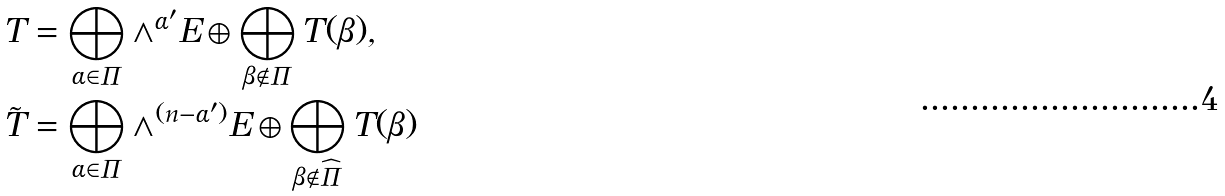<formula> <loc_0><loc_0><loc_500><loc_500>T & = \bigoplus _ { \alpha \in \Pi } \wedge ^ { \alpha ^ { \prime } } E \oplus \bigoplus _ { \beta \notin \Pi } T ( \beta ) , \\ \tilde { T } & = \bigoplus _ { \alpha \in \Pi } \wedge ^ { ( n - \alpha ^ { \prime } ) } E \oplus \bigoplus _ { \beta \notin \widehat { \Pi } } T ( \beta )</formula> 